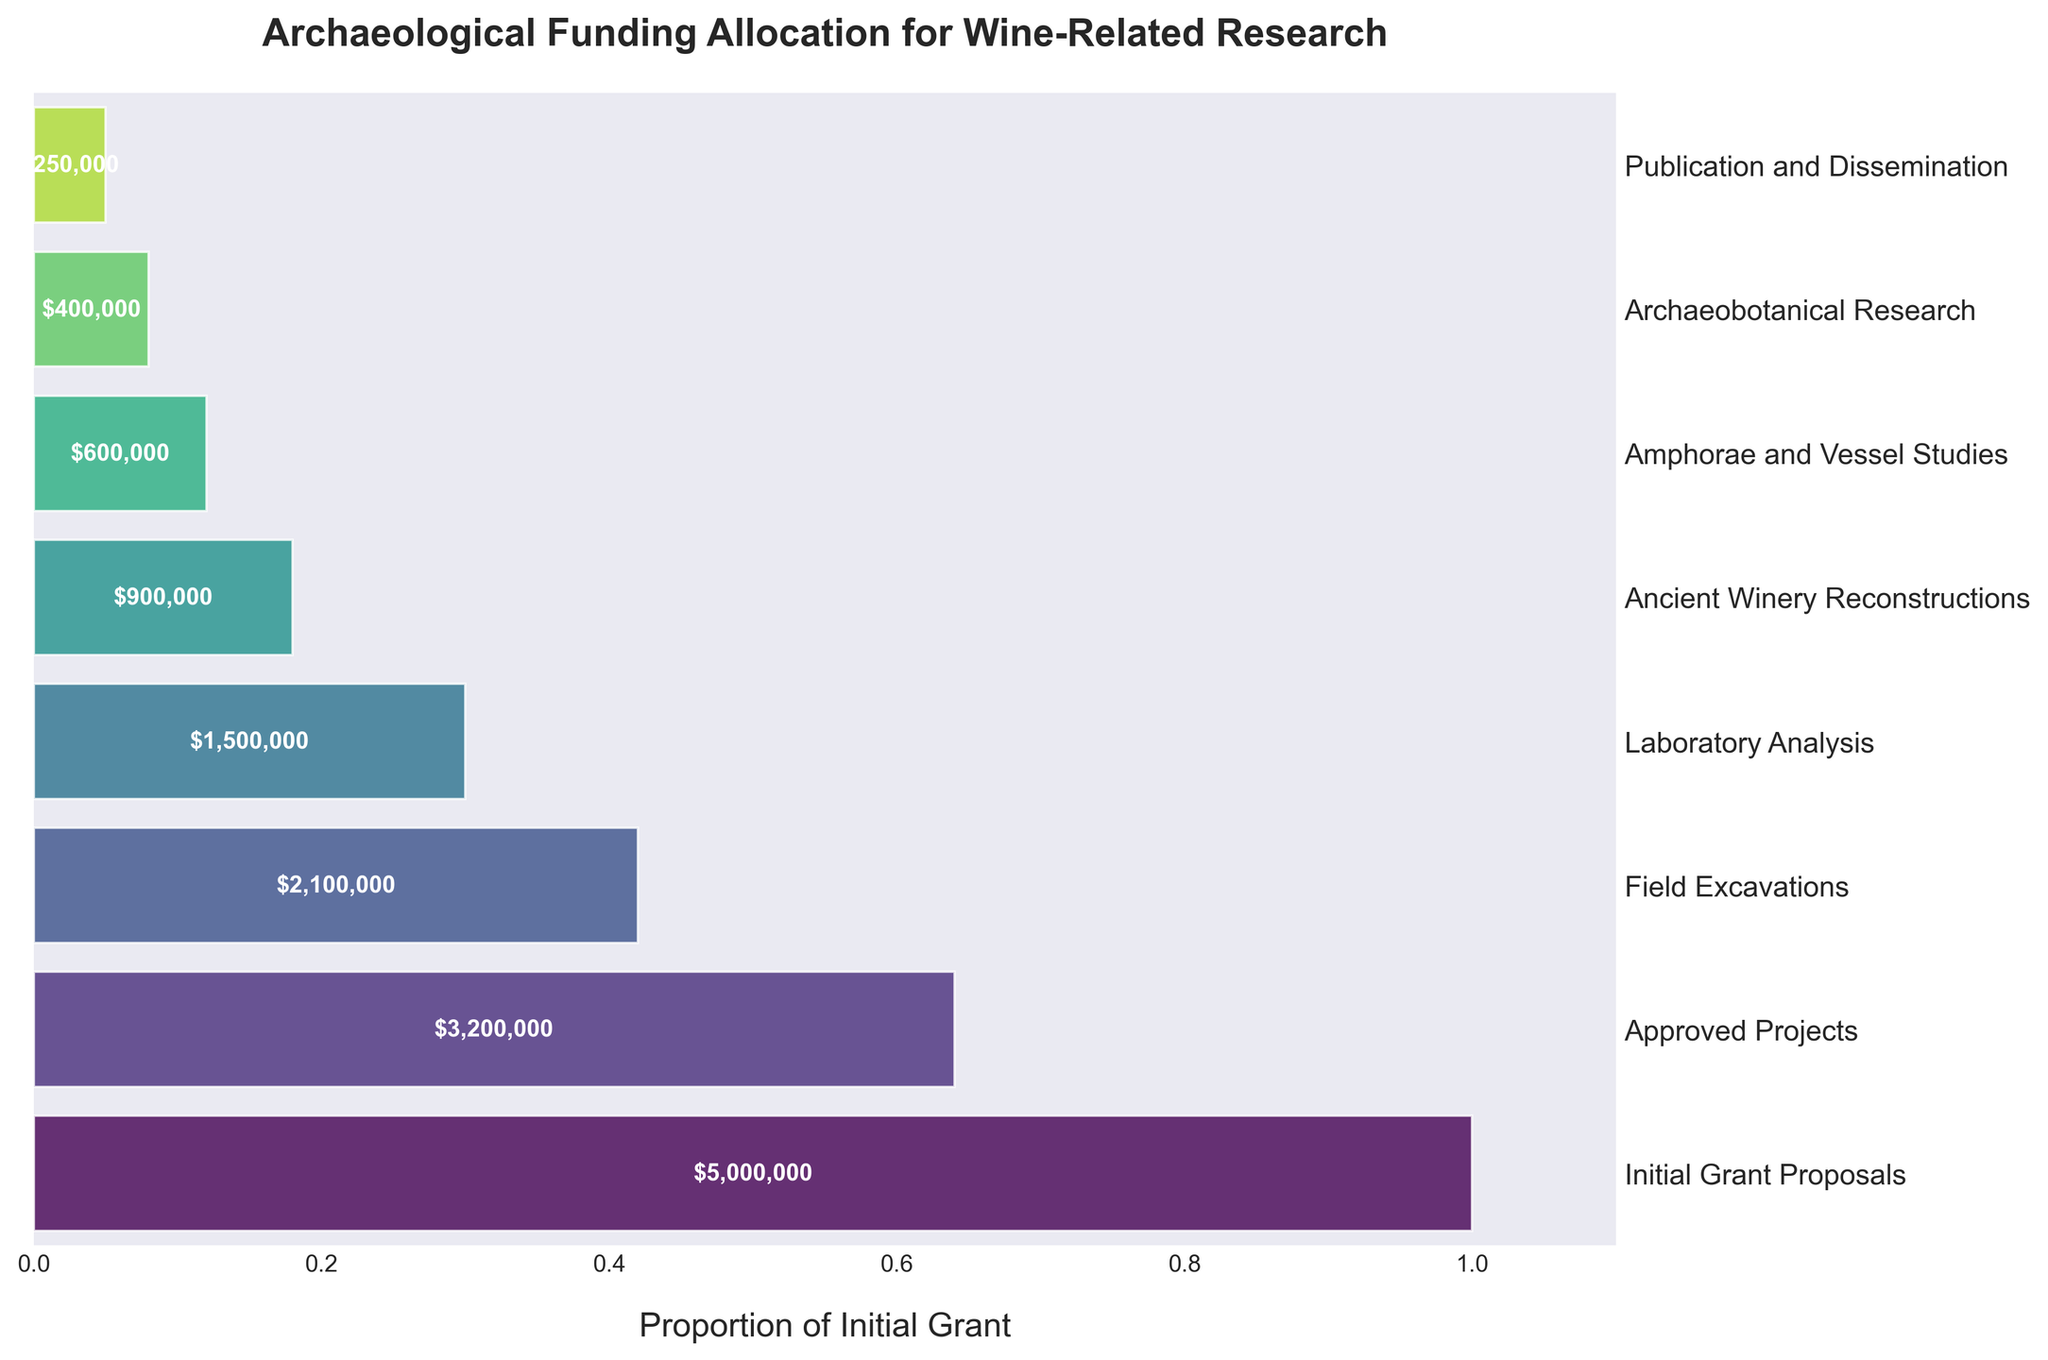What is the total funding allocation for "Field Excavations"? Locate "Field Excavations" on the y-axis and read off the corresponding funding value from the bar. The value is $2,100,000.
Answer: $2,100,000 What is the stage with the largest funding allocation? Observe the height of bars, "Initial Grant Proposals" has the tallest bar, indicating the largest funding allocation of $5,000,000.
Answer: Initial Grant Proposals How much more funding was allocated to "Laboratory Analysis" compared to "Archaeobotanical Research"? Find the funding amounts for both stages; $1,500,000 for "Laboratory Analysis" and $400,000 for "Archaeobotanical Research". Subtract $400,000 from $1,500,000.
Answer: $1,100,000 What percentage of the initial grant was allocated to "Ancient Winery Reconstructions"? The initial grant total is $5,000,000. The funding for "Ancient Winery Reconstructions" is $900,000. Divide $900,000 by $5,000,000 and multiply by 100%.
Answer: 18% What is the sum of the funding allocations for "Amphorae and Vessel Studies" and "Archaeobotanical Research"? Add the funding allocations for both stages: $600,000 for "Amphorae and Vessel Studies" and $400,000 for "Archaeobotanical Research".
Answer: $1,000,000 Which stage receives the least funding allocation? Find the shortest bar compared to others. "Publication and Dissemination" has the smallest amount of $250,000.
Answer: Publication and Dissemination How much less is the funding for "Approved Projects" than for the "Initial Grant Proposals"? The funding for "Initial Grant Proposals" is $5,000,000 and for "Approved Projects" is $3,200,000. Subtract $3,200,000 from $5,000,000.
Answer: $1,800,000 What is the average funding allocation for all the stages? Sum all the funding values: $5,000,000 + $3,200,000 + $2,100,000 + $1,500,000 + $900,000 + $600,000 + $400,000 + $250,000 = $13,950,000. Divide by the number of stages (8).
Answer: $1,743,750 